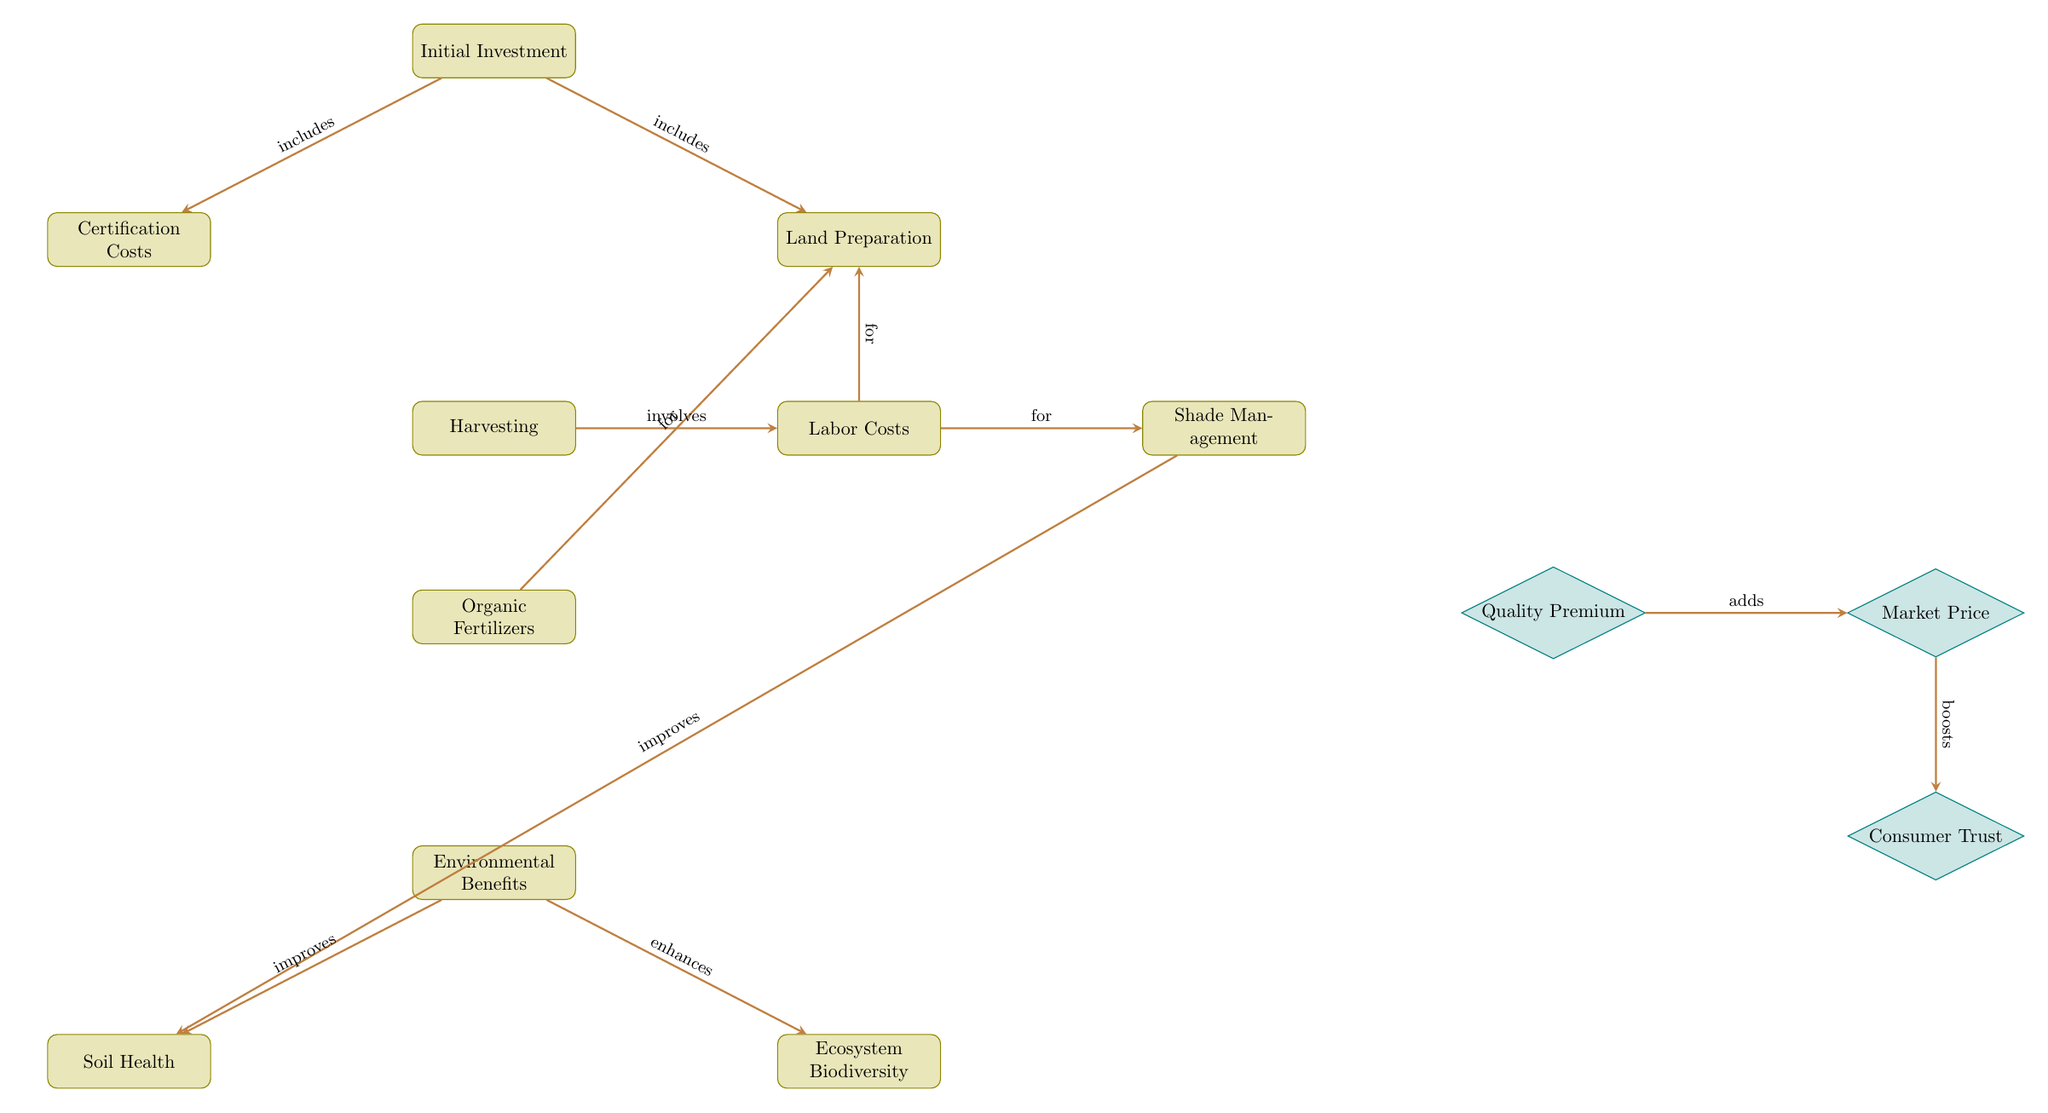What is included in the Initial Investment? The Initial Investment node leads to both Certification Costs and Land Preparation, indicating that these costs are part of the overall initial investment for organic coffee production.
Answer: Certification Costs, Land Preparation How many primary processes are shown in the diagram? The diagram displays a total of 7 primary process nodes: Initial Investment, Certification Costs, Land Preparation, Labor Costs, Shade Management, Harvesting, and Environmental Benefits.
Answer: 7 What does Shade Management improve? Shade Management directly connects to the Soil Health node, indicating that it has a positive influence on soil health through proper shading techniques.
Answer: Soil Health What adds to the Market Price? The diagram shows a directed connection from the Quality Premium node to the Market Price node, indicating that the quality premium enhances or adds to the price of organic coffee in the market.
Answer: Quality Premium What is the final outcome of the Economic Benefits group? The final node that links from the Market Price is Consumer Trust, which indicates that the economic benefits of organic coffee production ultimately lead to increased consumer trust in the product.
Answer: Consumer Trust Which process involves Labor Costs? The node Harvesting is connected to Labor Costs, indicating that harvesting is a labor-intensive process that contributes to the overall labor costs incurred in coffee production.
Answer: Harvesting What does Environmental Benefits enhance? The Environmental Benefits node connects to Ecosystem Biodiversity, suggesting that the environmental practices in organic farming enhance biodiversity within the ecosystem.
Answer: Ecosystem Biodiversity 